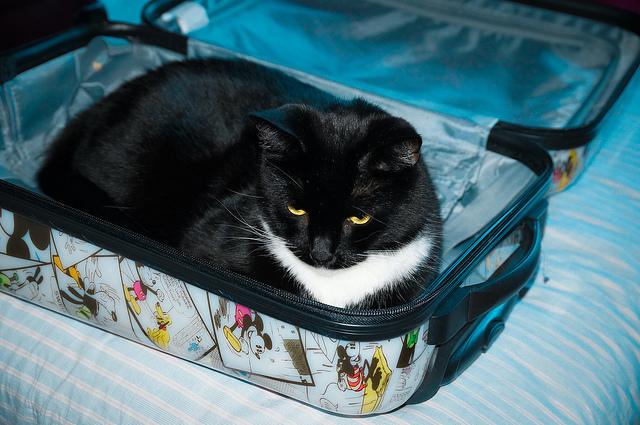What color is the cat?
Give a very brief answer. Black and white. What is this cat sitting in?
Write a very short answer. Suitcase. What is the cat laying in?
Short answer required. Suitcase. What cartoon company do the characters belong to?
Concise answer only. Disney. What color is the suitcase?
Quick response, please. White. 